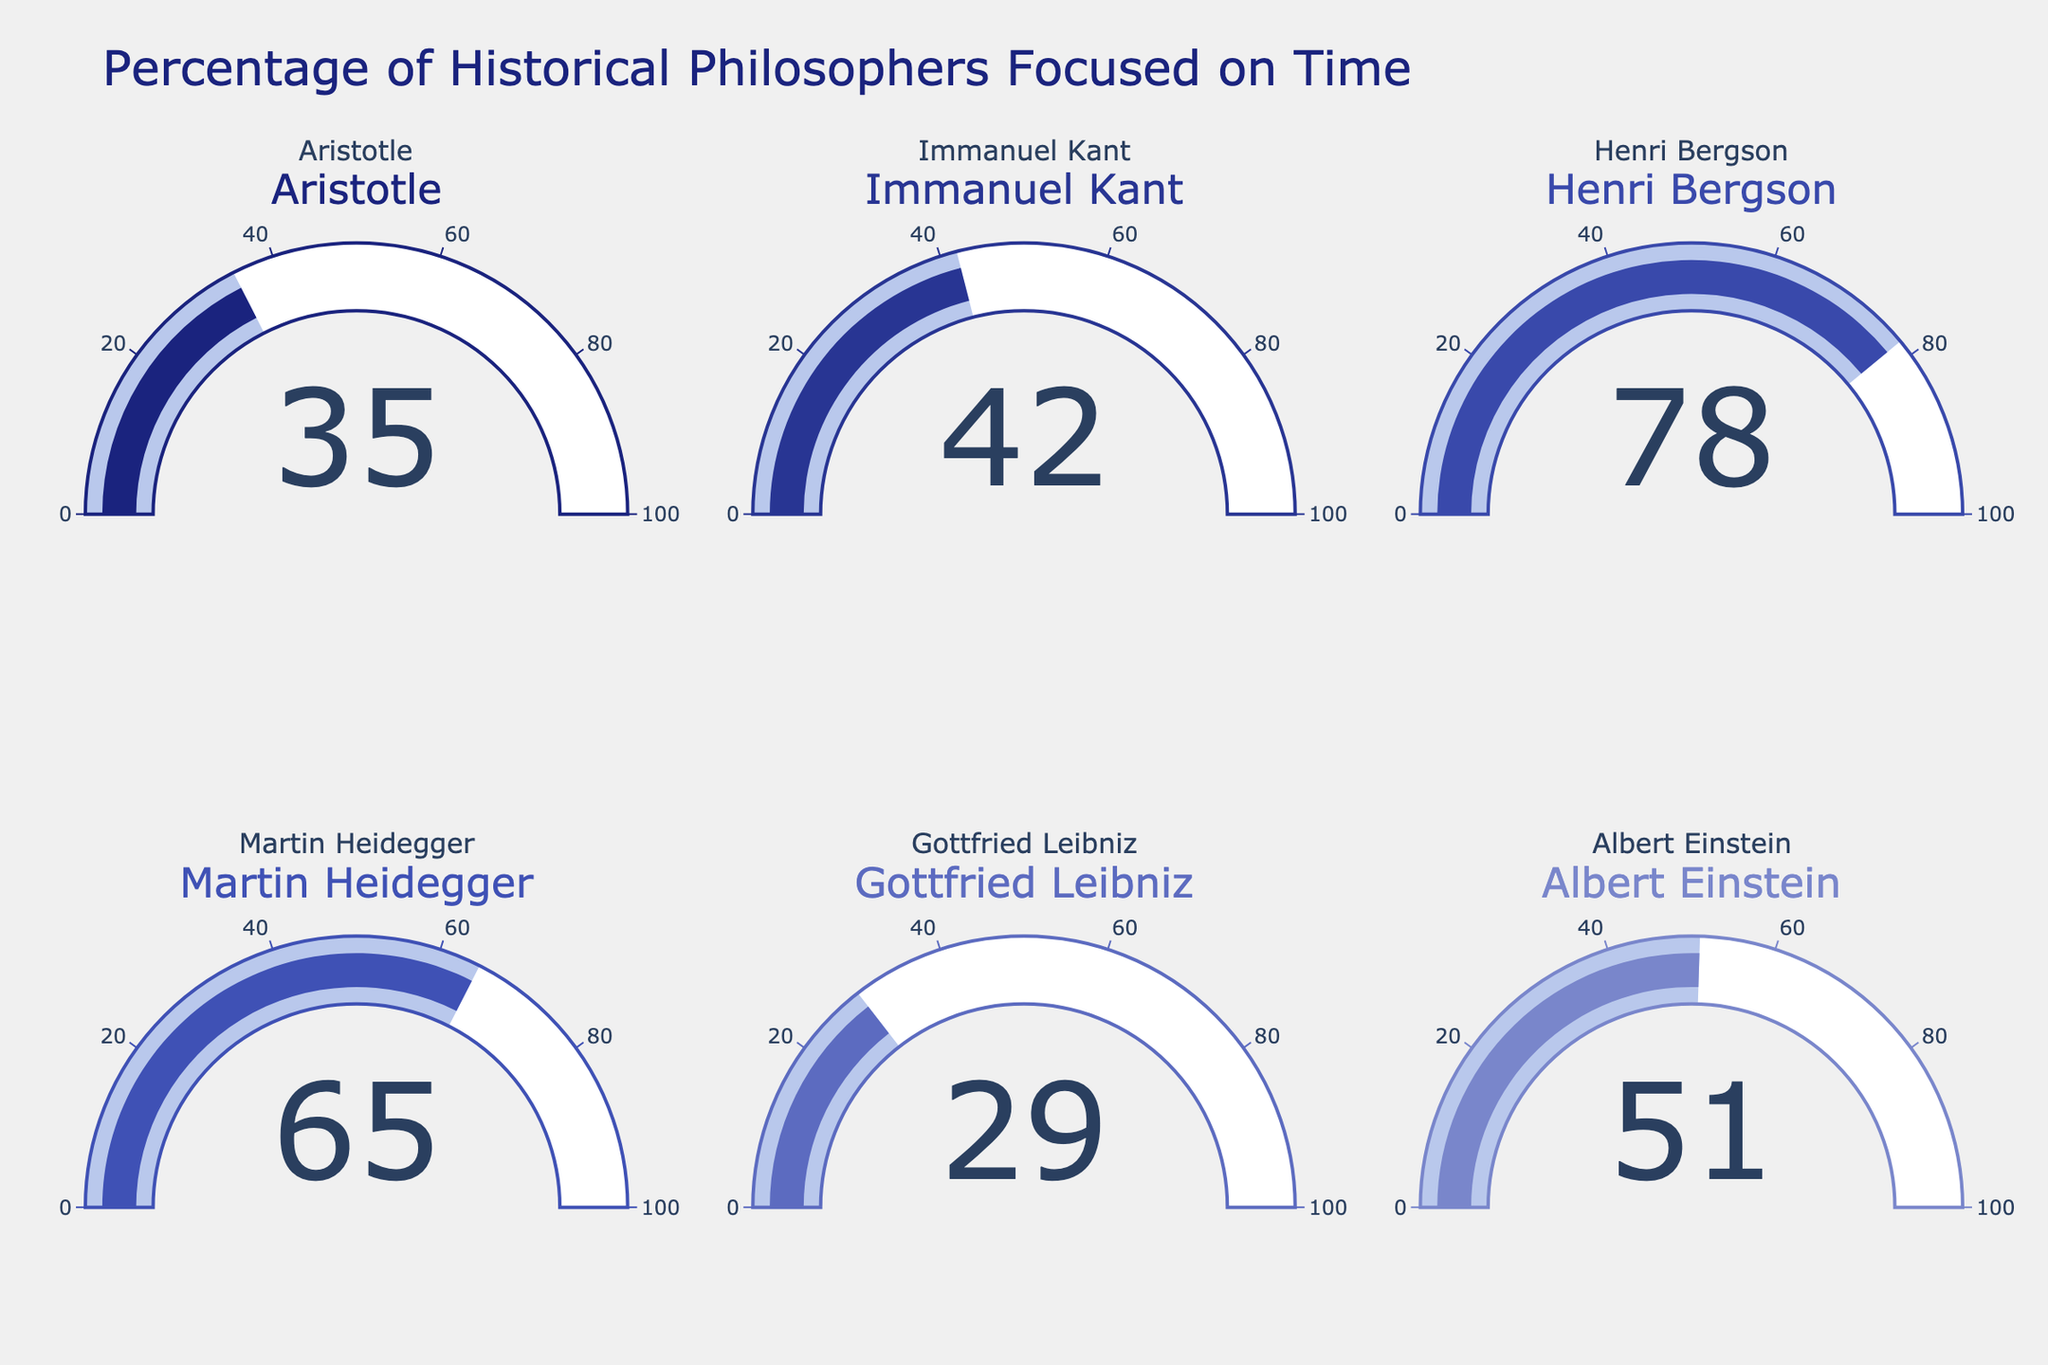Which philosopher has the highest percentage of focus on the nature of time? Henri Bergson has the highest percentage displayed on the gauge, which is 78%.
Answer: Henri Bergson Among Aristotle and Leibniz, who focused less on the nature of time? By looking at the gauges for Aristotle and Leibniz, Leibniz has a lower percentage (29%) compared to Aristotle (35%).
Answer: Gottfried Leibniz What is the average percentage of focus on the nature of time among the philosophers shown? Add all the percentages: 35 (Aristotle) + 42 (Kant) + 78 (Bergson) + 65 (Heidegger) + 29 (Leibniz) + 51 (Einstein) and divide by the number of philosophers (6). The sum is 300, so the average is 300 / 6 = 50.
Answer: 50 Is there any philosopher with a focus percentage above 70%? By skimming through the gauges, Henri Bergson, with 78%, is the only philosopher with a percentage above 70%.
Answer: Yes How much more does Martin Heidegger focus on the nature of time compared to Aristotle? Martin Heidegger has a focus percentage of 65%, while Aristotle's is 35%. The difference is 65 - 35 = 30.
Answer: 30 Which philosopher has a percent focus closest to the median of all the values shown? Sorting the percentages: 29 (Leibniz), 35 (Aristotle), 42 (Kant), 51 (Einstein), 65 (Heidegger), and 78 (Bergson). The median of these six values is the average of the 3rd and 4th values, which is (42 + 51) / 2 = 46.5. Immanuel Kant with 42% is closest to the median.
Answer: Immanuel Kant Do Immanuel Kant and Albert Einstein have an equal focus on the nature of time? By observing the gauges for both philosophers, Kant has 42% and Einstein has 51%, indicating they do not have equal percentages.
Answer: No Is Aristotle’s focus on time above the average focus percentage of all philosophers shown? The average percentage is 50 (from a previous calculation), and Aristotle's focus is 35%, which is below the average.
Answer: No 